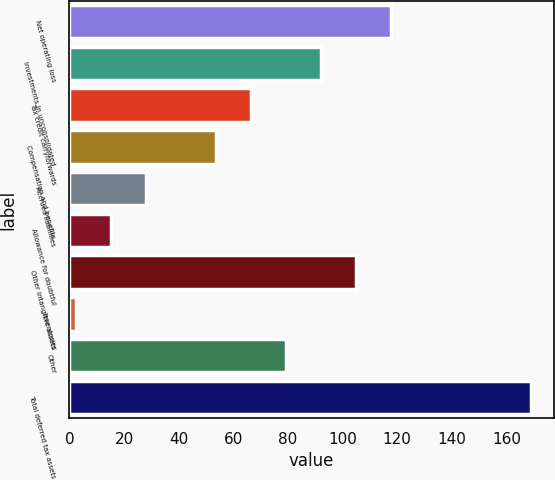Convert chart to OTSL. <chart><loc_0><loc_0><loc_500><loc_500><bar_chart><fcel>Net operating loss<fcel>Investments in unconsolidated<fcel>Tax credit carryforwards<fcel>Compensation and benefits<fcel>Accrued liabilities<fcel>Allowance for doubtful<fcel>Other intangible assets<fcel>Inventories<fcel>Other<fcel>Total deferred tax assets<nl><fcel>117.71<fcel>92.13<fcel>66.55<fcel>53.76<fcel>28.18<fcel>15.39<fcel>104.92<fcel>2.6<fcel>79.34<fcel>168.87<nl></chart> 